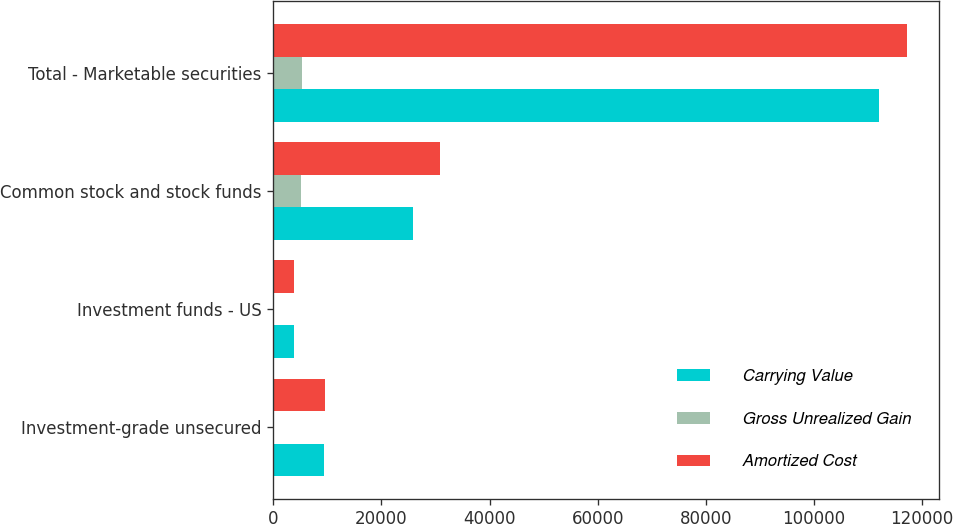Convert chart. <chart><loc_0><loc_0><loc_500><loc_500><stacked_bar_chart><ecel><fcel>Investment-grade unsecured<fcel>Investment funds - US<fcel>Common stock and stock funds<fcel>Total - Marketable securities<nl><fcel>Carrying Value<fcel>9435<fcel>3769<fcel>25755<fcel>111955<nl><fcel>Gross Unrealized Gain<fcel>145<fcel>3<fcel>5137<fcel>5285<nl><fcel>Amortized Cost<fcel>9580<fcel>3772<fcel>30892<fcel>117240<nl></chart> 